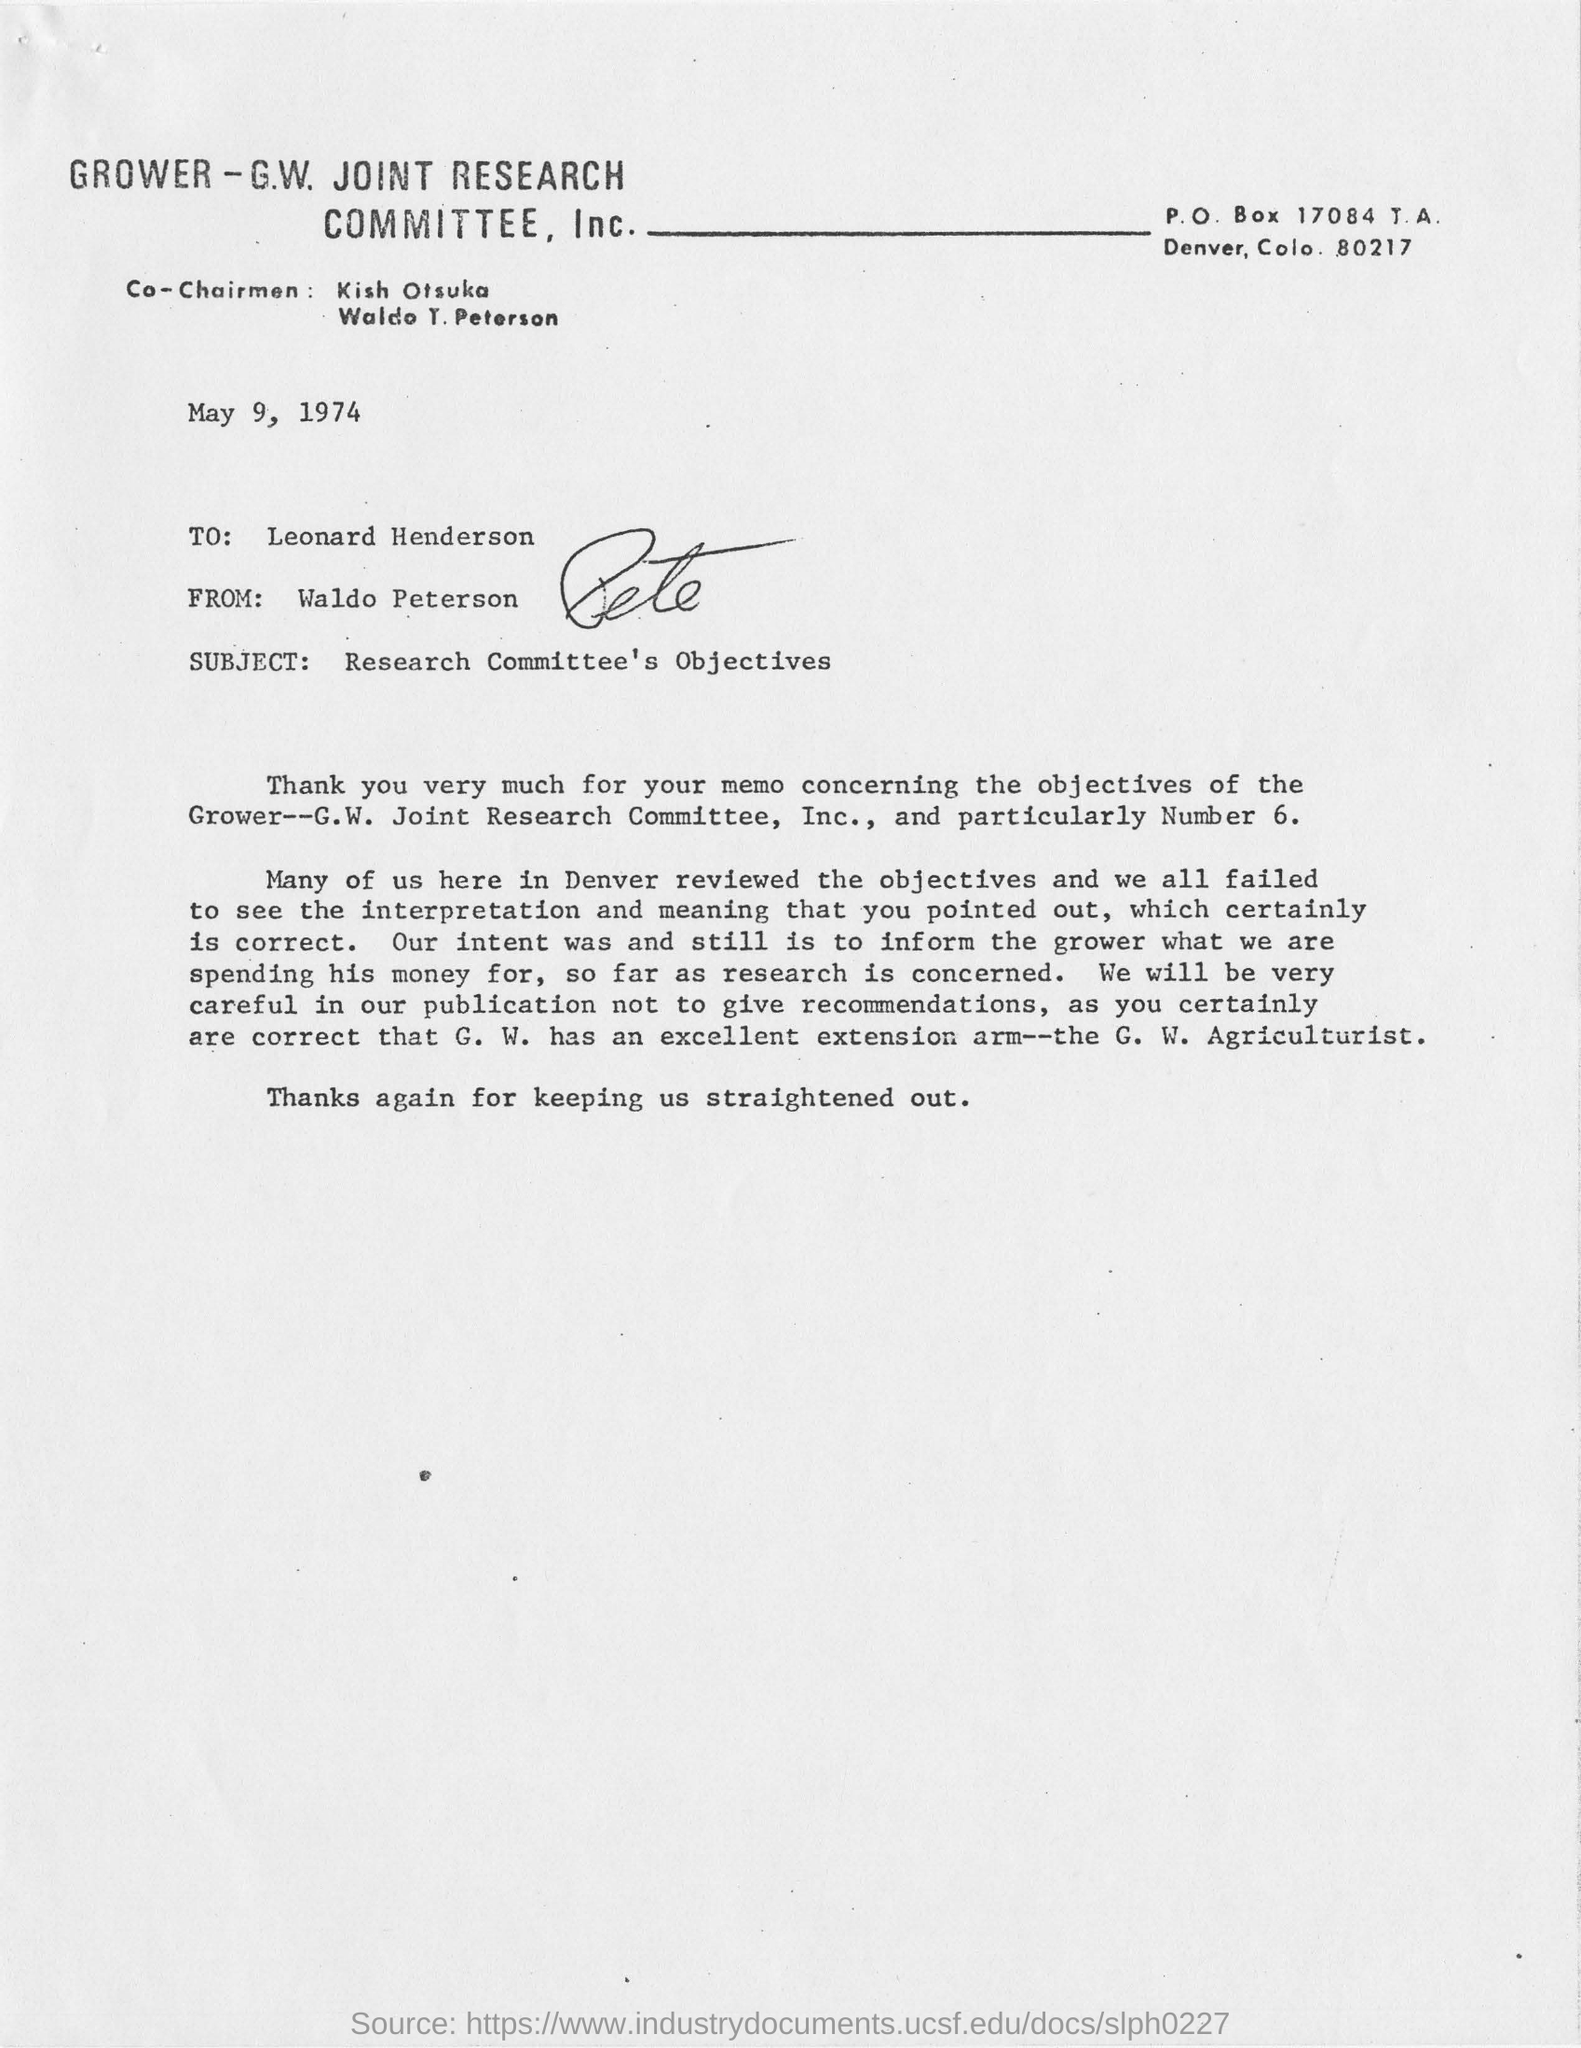Mention a couple of crucial points in this snapshot. The subject of this memo is the Research Committee's objectives. The subject of this letter is the research committee's objectives. The document was created on May 9, 1974. Leonard Henderson is the recipient of the letter. 